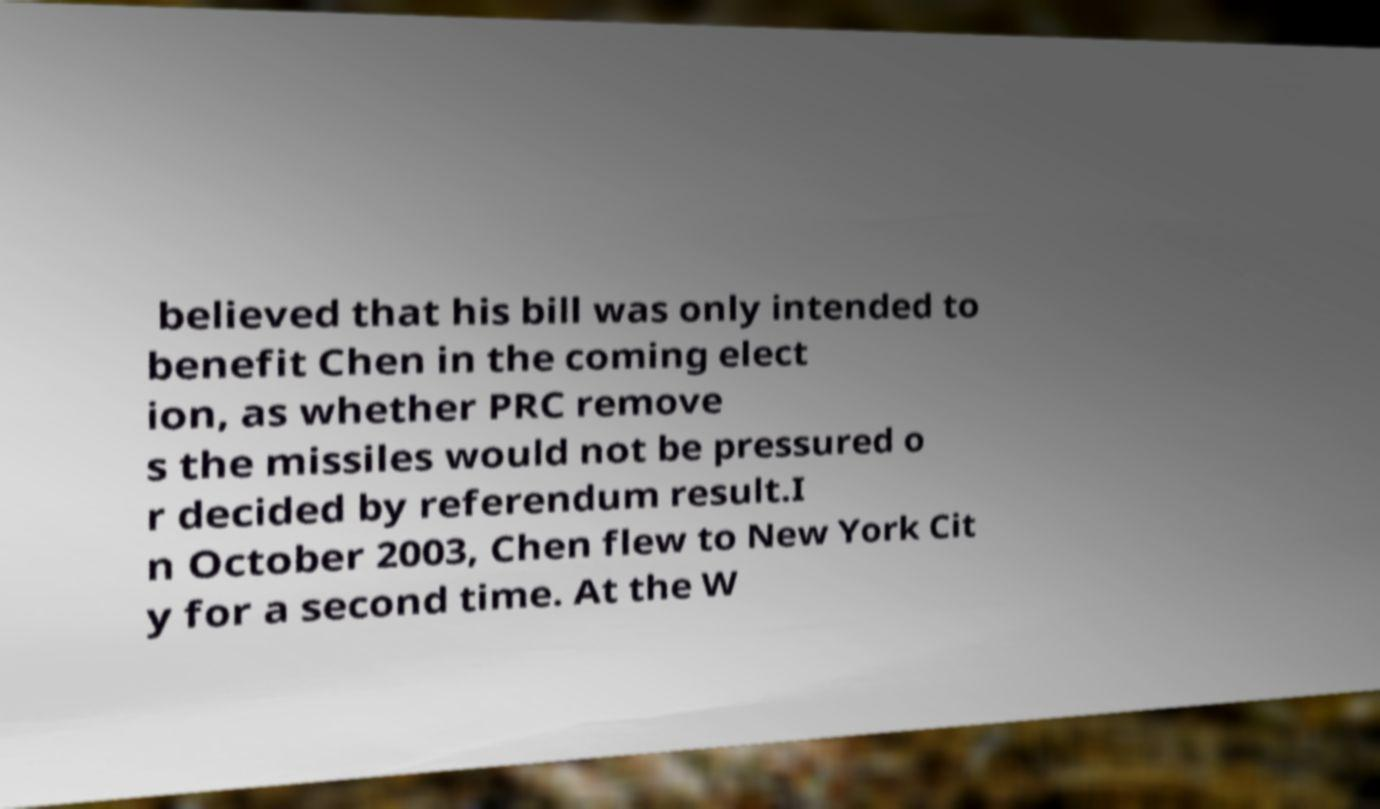Could you extract and type out the text from this image? believed that his bill was only intended to benefit Chen in the coming elect ion, as whether PRC remove s the missiles would not be pressured o r decided by referendum result.I n October 2003, Chen flew to New York Cit y for a second time. At the W 